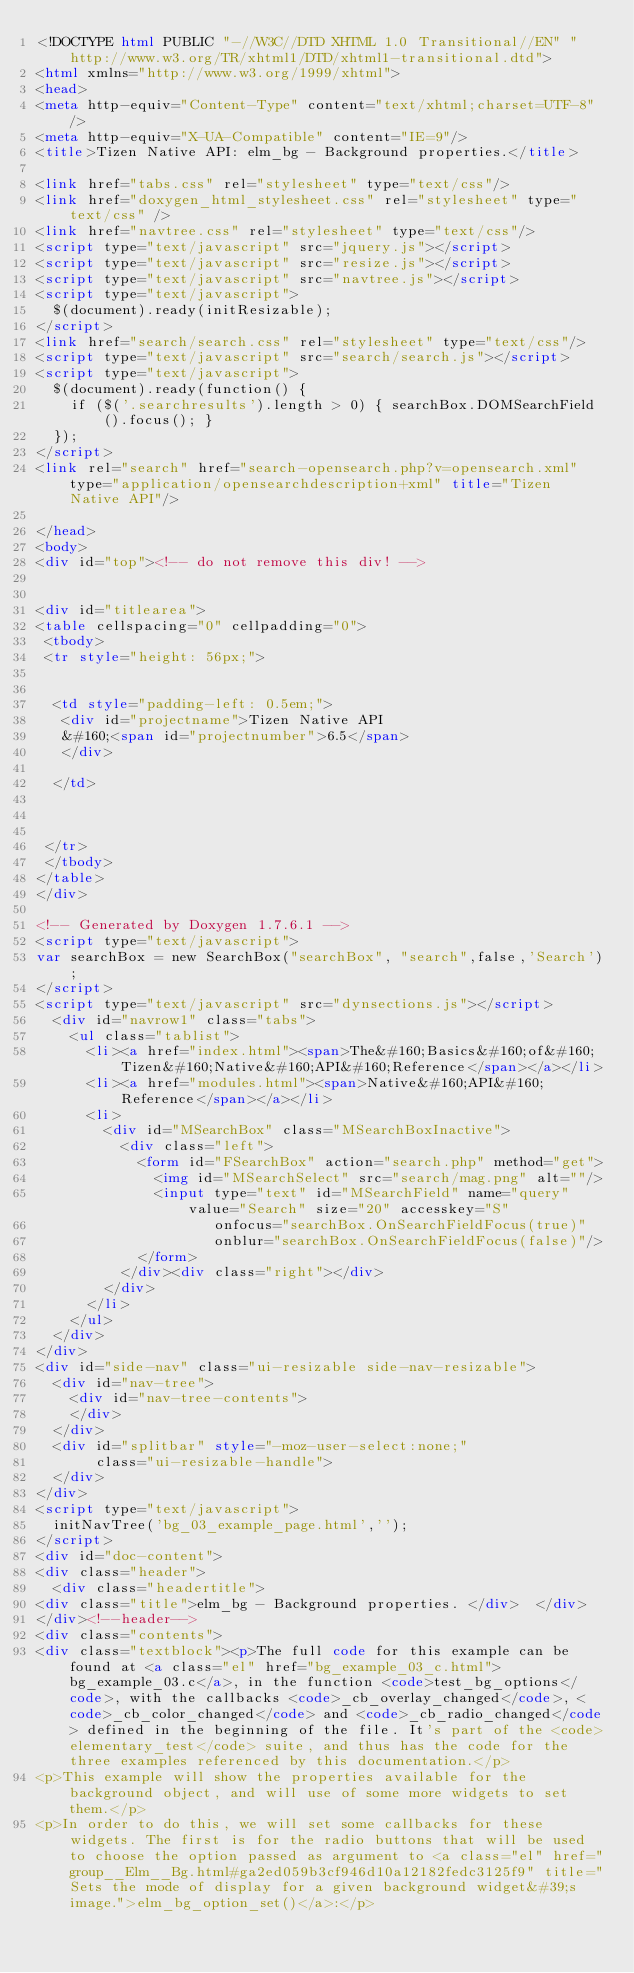Convert code to text. <code><loc_0><loc_0><loc_500><loc_500><_HTML_><!DOCTYPE html PUBLIC "-//W3C//DTD XHTML 1.0 Transitional//EN" "http://www.w3.org/TR/xhtml1/DTD/xhtml1-transitional.dtd">
<html xmlns="http://www.w3.org/1999/xhtml">
<head>
<meta http-equiv="Content-Type" content="text/xhtml;charset=UTF-8"/>
<meta http-equiv="X-UA-Compatible" content="IE=9"/>
<title>Tizen Native API: elm_bg - Background properties.</title>

<link href="tabs.css" rel="stylesheet" type="text/css"/>
<link href="doxygen_html_stylesheet.css" rel="stylesheet" type="text/css" />
<link href="navtree.css" rel="stylesheet" type="text/css"/>
<script type="text/javascript" src="jquery.js"></script>
<script type="text/javascript" src="resize.js"></script>
<script type="text/javascript" src="navtree.js"></script>
<script type="text/javascript">
  $(document).ready(initResizable);
</script>
<link href="search/search.css" rel="stylesheet" type="text/css"/>
<script type="text/javascript" src="search/search.js"></script>
<script type="text/javascript">
  $(document).ready(function() {
    if ($('.searchresults').length > 0) { searchBox.DOMSearchField().focus(); }
  });
</script>
<link rel="search" href="search-opensearch.php?v=opensearch.xml" type="application/opensearchdescription+xml" title="Tizen Native API"/>

</head>
<body>
<div id="top"><!-- do not remove this div! -->


<div id="titlearea">
<table cellspacing="0" cellpadding="0">
 <tbody>
 <tr style="height: 56px;">
  
  
  <td style="padding-left: 0.5em;">
   <div id="projectname">Tizen Native API
   &#160;<span id="projectnumber">6.5</span>
   </div>
   
  </td>
  
  
  
 </tr>
 </tbody>
</table>
</div>

<!-- Generated by Doxygen 1.7.6.1 -->
<script type="text/javascript">
var searchBox = new SearchBox("searchBox", "search",false,'Search');
</script>
<script type="text/javascript" src="dynsections.js"></script>
  <div id="navrow1" class="tabs">
    <ul class="tablist">
      <li><a href="index.html"><span>The&#160;Basics&#160;of&#160;Tizen&#160;Native&#160;API&#160;Reference</span></a></li>
      <li><a href="modules.html"><span>Native&#160;API&#160;Reference</span></a></li>
      <li>
        <div id="MSearchBox" class="MSearchBoxInactive">
          <div class="left">
            <form id="FSearchBox" action="search.php" method="get">
              <img id="MSearchSelect" src="search/mag.png" alt=""/>
              <input type="text" id="MSearchField" name="query" value="Search" size="20" accesskey="S" 
                     onfocus="searchBox.OnSearchFieldFocus(true)" 
                     onblur="searchBox.OnSearchFieldFocus(false)"/>
            </form>
          </div><div class="right"></div>
        </div>
      </li>
    </ul>
  </div>
</div>
<div id="side-nav" class="ui-resizable side-nav-resizable">
  <div id="nav-tree">
    <div id="nav-tree-contents">
    </div>
  </div>
  <div id="splitbar" style="-moz-user-select:none;" 
       class="ui-resizable-handle">
  </div>
</div>
<script type="text/javascript">
  initNavTree('bg_03_example_page.html','');
</script>
<div id="doc-content">
<div class="header">
  <div class="headertitle">
<div class="title">elm_bg - Background properties. </div>  </div>
</div><!--header-->
<div class="contents">
<div class="textblock"><p>The full code for this example can be found at <a class="el" href="bg_example_03_c.html">bg_example_03.c</a>, in the function <code>test_bg_options</code>, with the callbacks <code>_cb_overlay_changed</code>, <code>_cb_color_changed</code> and <code>_cb_radio_changed</code> defined in the beginning of the file. It's part of the <code>elementary_test</code> suite, and thus has the code for the three examples referenced by this documentation.</p>
<p>This example will show the properties available for the background object, and will use of some more widgets to set them.</p>
<p>In order to do this, we will set some callbacks for these widgets. The first is for the radio buttons that will be used to choose the option passed as argument to <a class="el" href="group__Elm__Bg.html#ga2ed059b3cf946d10a12182fedc3125f9" title="Sets the mode of display for a given background widget&#39;s image.">elm_bg_option_set()</a>:</p></code> 